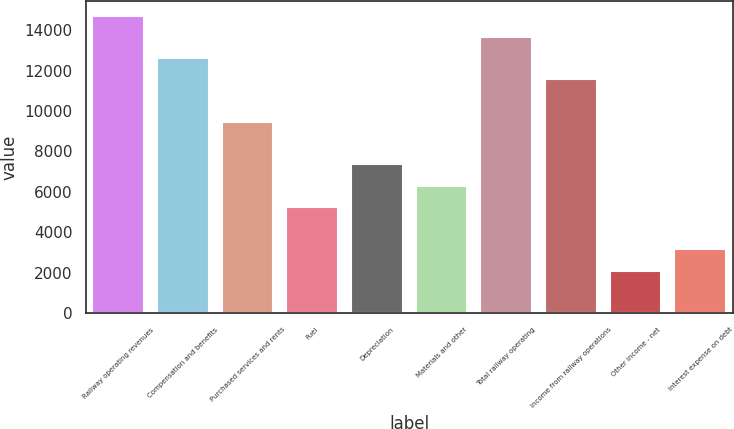Convert chart to OTSL. <chart><loc_0><loc_0><loc_500><loc_500><bar_chart><fcel>Railway operating revenues<fcel>Compensation and benefits<fcel>Purchased services and rents<fcel>Fuel<fcel>Depreciation<fcel>Materials and other<fcel>Total railway operating<fcel>Income from railway operations<fcel>Other income - net<fcel>Interest expense on debt<nl><fcel>14713.4<fcel>12612.2<fcel>9460.41<fcel>5258.05<fcel>7359.23<fcel>6308.64<fcel>13662.8<fcel>11561.6<fcel>2106.28<fcel>3156.87<nl></chart> 